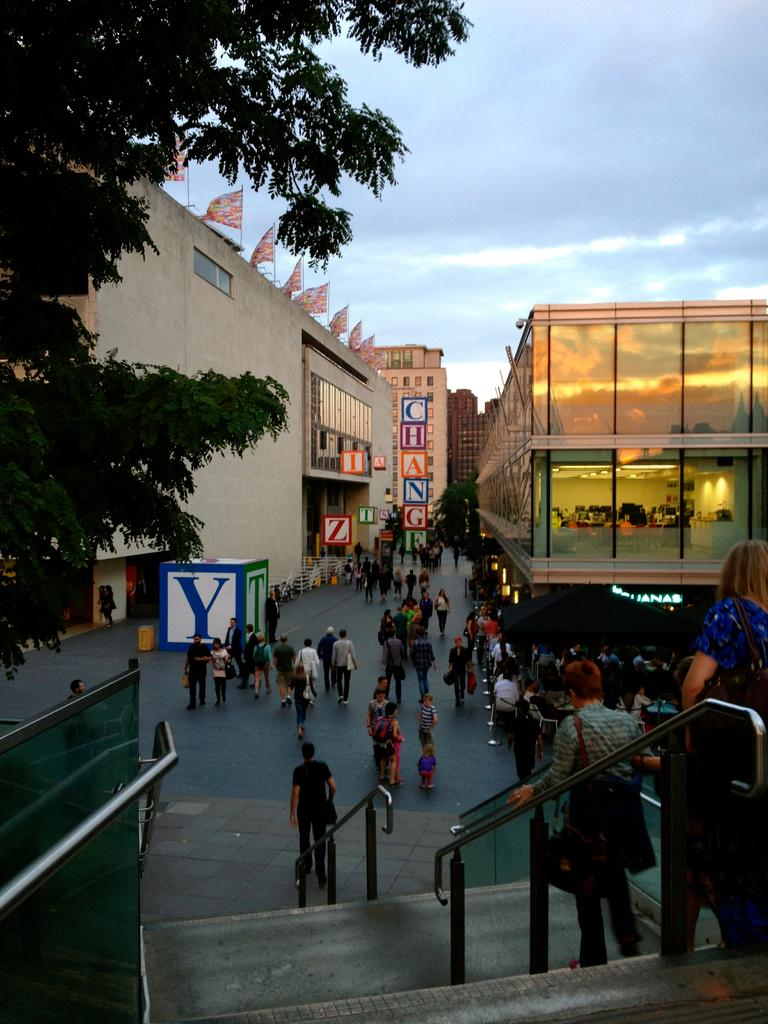What is located on the left side of the image? There is a tree and a building on the left side of the image. What is a feature of the building in the image? Flags are present on the building. What can be seen in the bottom right of the image? There is a roof in the bottom right of the image. What is visible in the background of the image? The sky is visible in the background of the image. What type of creature is sitting on the furniture in the image? There is no furniture or creature present in the image. What color is the cloud in the image? There are no clouds visible in the image; only the sky is present in the background. 